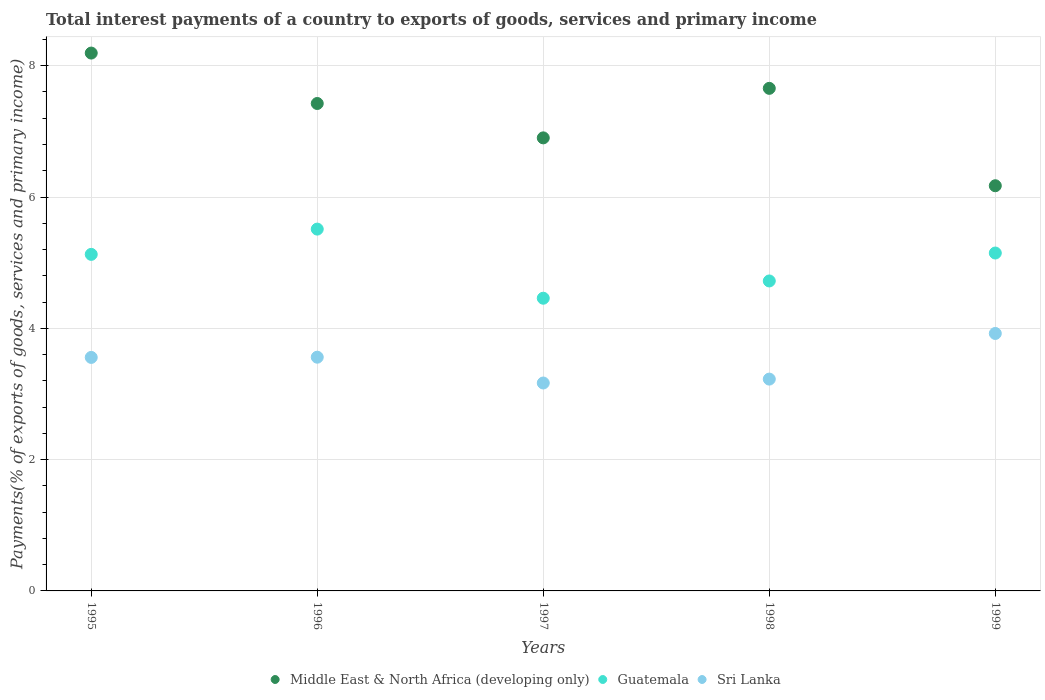Is the number of dotlines equal to the number of legend labels?
Keep it short and to the point. Yes. What is the total interest payments in Guatemala in 1997?
Offer a terse response. 4.46. Across all years, what is the maximum total interest payments in Sri Lanka?
Make the answer very short. 3.92. Across all years, what is the minimum total interest payments in Sri Lanka?
Your answer should be compact. 3.17. What is the total total interest payments in Guatemala in the graph?
Give a very brief answer. 24.96. What is the difference between the total interest payments in Guatemala in 1996 and that in 1998?
Offer a very short reply. 0.79. What is the difference between the total interest payments in Middle East & North Africa (developing only) in 1995 and the total interest payments in Sri Lanka in 1997?
Keep it short and to the point. 5.03. What is the average total interest payments in Guatemala per year?
Your answer should be very brief. 4.99. In the year 1998, what is the difference between the total interest payments in Guatemala and total interest payments in Middle East & North Africa (developing only)?
Provide a succinct answer. -2.93. In how many years, is the total interest payments in Sri Lanka greater than 1.2000000000000002 %?
Your response must be concise. 5. What is the ratio of the total interest payments in Middle East & North Africa (developing only) in 1995 to that in 1996?
Your response must be concise. 1.1. What is the difference between the highest and the second highest total interest payments in Guatemala?
Provide a succinct answer. 0.36. What is the difference between the highest and the lowest total interest payments in Sri Lanka?
Make the answer very short. 0.75. Is the sum of the total interest payments in Guatemala in 1996 and 1998 greater than the maximum total interest payments in Middle East & North Africa (developing only) across all years?
Keep it short and to the point. Yes. Is it the case that in every year, the sum of the total interest payments in Guatemala and total interest payments in Middle East & North Africa (developing only)  is greater than the total interest payments in Sri Lanka?
Give a very brief answer. Yes. Is the total interest payments in Guatemala strictly greater than the total interest payments in Sri Lanka over the years?
Keep it short and to the point. Yes. How many dotlines are there?
Offer a terse response. 3. What is the difference between two consecutive major ticks on the Y-axis?
Offer a very short reply. 2. Are the values on the major ticks of Y-axis written in scientific E-notation?
Keep it short and to the point. No. Does the graph contain grids?
Offer a very short reply. Yes. Where does the legend appear in the graph?
Make the answer very short. Bottom center. What is the title of the graph?
Keep it short and to the point. Total interest payments of a country to exports of goods, services and primary income. Does "St. Martin (French part)" appear as one of the legend labels in the graph?
Provide a short and direct response. No. What is the label or title of the X-axis?
Provide a short and direct response. Years. What is the label or title of the Y-axis?
Ensure brevity in your answer.  Payments(% of exports of goods, services and primary income). What is the Payments(% of exports of goods, services and primary income) of Middle East & North Africa (developing only) in 1995?
Offer a terse response. 8.19. What is the Payments(% of exports of goods, services and primary income) in Guatemala in 1995?
Your answer should be compact. 5.13. What is the Payments(% of exports of goods, services and primary income) of Sri Lanka in 1995?
Ensure brevity in your answer.  3.56. What is the Payments(% of exports of goods, services and primary income) in Middle East & North Africa (developing only) in 1996?
Offer a very short reply. 7.42. What is the Payments(% of exports of goods, services and primary income) in Guatemala in 1996?
Your answer should be very brief. 5.51. What is the Payments(% of exports of goods, services and primary income) of Sri Lanka in 1996?
Your answer should be compact. 3.56. What is the Payments(% of exports of goods, services and primary income) of Middle East & North Africa (developing only) in 1997?
Your answer should be very brief. 6.9. What is the Payments(% of exports of goods, services and primary income) in Guatemala in 1997?
Provide a succinct answer. 4.46. What is the Payments(% of exports of goods, services and primary income) of Sri Lanka in 1997?
Keep it short and to the point. 3.17. What is the Payments(% of exports of goods, services and primary income) in Middle East & North Africa (developing only) in 1998?
Your answer should be compact. 7.66. What is the Payments(% of exports of goods, services and primary income) of Guatemala in 1998?
Give a very brief answer. 4.72. What is the Payments(% of exports of goods, services and primary income) in Sri Lanka in 1998?
Offer a very short reply. 3.23. What is the Payments(% of exports of goods, services and primary income) of Middle East & North Africa (developing only) in 1999?
Provide a succinct answer. 6.17. What is the Payments(% of exports of goods, services and primary income) in Guatemala in 1999?
Your answer should be compact. 5.15. What is the Payments(% of exports of goods, services and primary income) of Sri Lanka in 1999?
Provide a succinct answer. 3.92. Across all years, what is the maximum Payments(% of exports of goods, services and primary income) in Middle East & North Africa (developing only)?
Offer a terse response. 8.19. Across all years, what is the maximum Payments(% of exports of goods, services and primary income) of Guatemala?
Your answer should be very brief. 5.51. Across all years, what is the maximum Payments(% of exports of goods, services and primary income) in Sri Lanka?
Your answer should be very brief. 3.92. Across all years, what is the minimum Payments(% of exports of goods, services and primary income) of Middle East & North Africa (developing only)?
Your answer should be compact. 6.17. Across all years, what is the minimum Payments(% of exports of goods, services and primary income) of Guatemala?
Offer a very short reply. 4.46. Across all years, what is the minimum Payments(% of exports of goods, services and primary income) in Sri Lanka?
Your answer should be compact. 3.17. What is the total Payments(% of exports of goods, services and primary income) of Middle East & North Africa (developing only) in the graph?
Your answer should be very brief. 36.34. What is the total Payments(% of exports of goods, services and primary income) in Guatemala in the graph?
Provide a succinct answer. 24.96. What is the total Payments(% of exports of goods, services and primary income) in Sri Lanka in the graph?
Offer a terse response. 17.43. What is the difference between the Payments(% of exports of goods, services and primary income) of Middle East & North Africa (developing only) in 1995 and that in 1996?
Your response must be concise. 0.77. What is the difference between the Payments(% of exports of goods, services and primary income) of Guatemala in 1995 and that in 1996?
Provide a succinct answer. -0.38. What is the difference between the Payments(% of exports of goods, services and primary income) of Sri Lanka in 1995 and that in 1996?
Make the answer very short. -0. What is the difference between the Payments(% of exports of goods, services and primary income) in Middle East & North Africa (developing only) in 1995 and that in 1997?
Provide a short and direct response. 1.29. What is the difference between the Payments(% of exports of goods, services and primary income) of Guatemala in 1995 and that in 1997?
Ensure brevity in your answer.  0.67. What is the difference between the Payments(% of exports of goods, services and primary income) in Sri Lanka in 1995 and that in 1997?
Ensure brevity in your answer.  0.39. What is the difference between the Payments(% of exports of goods, services and primary income) of Middle East & North Africa (developing only) in 1995 and that in 1998?
Your answer should be very brief. 0.54. What is the difference between the Payments(% of exports of goods, services and primary income) of Guatemala in 1995 and that in 1998?
Give a very brief answer. 0.41. What is the difference between the Payments(% of exports of goods, services and primary income) of Sri Lanka in 1995 and that in 1998?
Make the answer very short. 0.33. What is the difference between the Payments(% of exports of goods, services and primary income) in Middle East & North Africa (developing only) in 1995 and that in 1999?
Provide a succinct answer. 2.02. What is the difference between the Payments(% of exports of goods, services and primary income) in Guatemala in 1995 and that in 1999?
Offer a very short reply. -0.02. What is the difference between the Payments(% of exports of goods, services and primary income) in Sri Lanka in 1995 and that in 1999?
Keep it short and to the point. -0.36. What is the difference between the Payments(% of exports of goods, services and primary income) of Middle East & North Africa (developing only) in 1996 and that in 1997?
Ensure brevity in your answer.  0.52. What is the difference between the Payments(% of exports of goods, services and primary income) of Guatemala in 1996 and that in 1997?
Your response must be concise. 1.05. What is the difference between the Payments(% of exports of goods, services and primary income) of Sri Lanka in 1996 and that in 1997?
Offer a very short reply. 0.39. What is the difference between the Payments(% of exports of goods, services and primary income) in Middle East & North Africa (developing only) in 1996 and that in 1998?
Your answer should be very brief. -0.23. What is the difference between the Payments(% of exports of goods, services and primary income) in Guatemala in 1996 and that in 1998?
Give a very brief answer. 0.79. What is the difference between the Payments(% of exports of goods, services and primary income) of Sri Lanka in 1996 and that in 1998?
Offer a terse response. 0.33. What is the difference between the Payments(% of exports of goods, services and primary income) of Middle East & North Africa (developing only) in 1996 and that in 1999?
Make the answer very short. 1.25. What is the difference between the Payments(% of exports of goods, services and primary income) of Guatemala in 1996 and that in 1999?
Your answer should be very brief. 0.36. What is the difference between the Payments(% of exports of goods, services and primary income) of Sri Lanka in 1996 and that in 1999?
Provide a short and direct response. -0.36. What is the difference between the Payments(% of exports of goods, services and primary income) in Middle East & North Africa (developing only) in 1997 and that in 1998?
Provide a succinct answer. -0.75. What is the difference between the Payments(% of exports of goods, services and primary income) in Guatemala in 1997 and that in 1998?
Offer a terse response. -0.26. What is the difference between the Payments(% of exports of goods, services and primary income) of Sri Lanka in 1997 and that in 1998?
Provide a short and direct response. -0.06. What is the difference between the Payments(% of exports of goods, services and primary income) of Middle East & North Africa (developing only) in 1997 and that in 1999?
Provide a succinct answer. 0.73. What is the difference between the Payments(% of exports of goods, services and primary income) of Guatemala in 1997 and that in 1999?
Make the answer very short. -0.69. What is the difference between the Payments(% of exports of goods, services and primary income) in Sri Lanka in 1997 and that in 1999?
Provide a succinct answer. -0.75. What is the difference between the Payments(% of exports of goods, services and primary income) of Middle East & North Africa (developing only) in 1998 and that in 1999?
Give a very brief answer. 1.48. What is the difference between the Payments(% of exports of goods, services and primary income) of Guatemala in 1998 and that in 1999?
Provide a short and direct response. -0.43. What is the difference between the Payments(% of exports of goods, services and primary income) of Sri Lanka in 1998 and that in 1999?
Offer a very short reply. -0.69. What is the difference between the Payments(% of exports of goods, services and primary income) in Middle East & North Africa (developing only) in 1995 and the Payments(% of exports of goods, services and primary income) in Guatemala in 1996?
Provide a short and direct response. 2.68. What is the difference between the Payments(% of exports of goods, services and primary income) of Middle East & North Africa (developing only) in 1995 and the Payments(% of exports of goods, services and primary income) of Sri Lanka in 1996?
Offer a terse response. 4.63. What is the difference between the Payments(% of exports of goods, services and primary income) in Guatemala in 1995 and the Payments(% of exports of goods, services and primary income) in Sri Lanka in 1996?
Offer a terse response. 1.57. What is the difference between the Payments(% of exports of goods, services and primary income) of Middle East & North Africa (developing only) in 1995 and the Payments(% of exports of goods, services and primary income) of Guatemala in 1997?
Offer a terse response. 3.73. What is the difference between the Payments(% of exports of goods, services and primary income) of Middle East & North Africa (developing only) in 1995 and the Payments(% of exports of goods, services and primary income) of Sri Lanka in 1997?
Your answer should be compact. 5.03. What is the difference between the Payments(% of exports of goods, services and primary income) in Guatemala in 1995 and the Payments(% of exports of goods, services and primary income) in Sri Lanka in 1997?
Provide a succinct answer. 1.96. What is the difference between the Payments(% of exports of goods, services and primary income) of Middle East & North Africa (developing only) in 1995 and the Payments(% of exports of goods, services and primary income) of Guatemala in 1998?
Make the answer very short. 3.47. What is the difference between the Payments(% of exports of goods, services and primary income) in Middle East & North Africa (developing only) in 1995 and the Payments(% of exports of goods, services and primary income) in Sri Lanka in 1998?
Ensure brevity in your answer.  4.97. What is the difference between the Payments(% of exports of goods, services and primary income) of Guatemala in 1995 and the Payments(% of exports of goods, services and primary income) of Sri Lanka in 1998?
Provide a short and direct response. 1.9. What is the difference between the Payments(% of exports of goods, services and primary income) in Middle East & North Africa (developing only) in 1995 and the Payments(% of exports of goods, services and primary income) in Guatemala in 1999?
Keep it short and to the point. 3.05. What is the difference between the Payments(% of exports of goods, services and primary income) of Middle East & North Africa (developing only) in 1995 and the Payments(% of exports of goods, services and primary income) of Sri Lanka in 1999?
Offer a very short reply. 4.27. What is the difference between the Payments(% of exports of goods, services and primary income) in Guatemala in 1995 and the Payments(% of exports of goods, services and primary income) in Sri Lanka in 1999?
Offer a terse response. 1.2. What is the difference between the Payments(% of exports of goods, services and primary income) of Middle East & North Africa (developing only) in 1996 and the Payments(% of exports of goods, services and primary income) of Guatemala in 1997?
Your answer should be compact. 2.97. What is the difference between the Payments(% of exports of goods, services and primary income) of Middle East & North Africa (developing only) in 1996 and the Payments(% of exports of goods, services and primary income) of Sri Lanka in 1997?
Your answer should be very brief. 4.26. What is the difference between the Payments(% of exports of goods, services and primary income) in Guatemala in 1996 and the Payments(% of exports of goods, services and primary income) in Sri Lanka in 1997?
Provide a short and direct response. 2.34. What is the difference between the Payments(% of exports of goods, services and primary income) of Middle East & North Africa (developing only) in 1996 and the Payments(% of exports of goods, services and primary income) of Guatemala in 1998?
Your response must be concise. 2.7. What is the difference between the Payments(% of exports of goods, services and primary income) in Middle East & North Africa (developing only) in 1996 and the Payments(% of exports of goods, services and primary income) in Sri Lanka in 1998?
Give a very brief answer. 4.2. What is the difference between the Payments(% of exports of goods, services and primary income) in Guatemala in 1996 and the Payments(% of exports of goods, services and primary income) in Sri Lanka in 1998?
Provide a short and direct response. 2.28. What is the difference between the Payments(% of exports of goods, services and primary income) in Middle East & North Africa (developing only) in 1996 and the Payments(% of exports of goods, services and primary income) in Guatemala in 1999?
Your answer should be compact. 2.28. What is the difference between the Payments(% of exports of goods, services and primary income) in Middle East & North Africa (developing only) in 1996 and the Payments(% of exports of goods, services and primary income) in Sri Lanka in 1999?
Offer a very short reply. 3.5. What is the difference between the Payments(% of exports of goods, services and primary income) in Guatemala in 1996 and the Payments(% of exports of goods, services and primary income) in Sri Lanka in 1999?
Offer a very short reply. 1.59. What is the difference between the Payments(% of exports of goods, services and primary income) of Middle East & North Africa (developing only) in 1997 and the Payments(% of exports of goods, services and primary income) of Guatemala in 1998?
Your response must be concise. 2.18. What is the difference between the Payments(% of exports of goods, services and primary income) in Middle East & North Africa (developing only) in 1997 and the Payments(% of exports of goods, services and primary income) in Sri Lanka in 1998?
Your response must be concise. 3.67. What is the difference between the Payments(% of exports of goods, services and primary income) of Guatemala in 1997 and the Payments(% of exports of goods, services and primary income) of Sri Lanka in 1998?
Keep it short and to the point. 1.23. What is the difference between the Payments(% of exports of goods, services and primary income) in Middle East & North Africa (developing only) in 1997 and the Payments(% of exports of goods, services and primary income) in Guatemala in 1999?
Ensure brevity in your answer.  1.75. What is the difference between the Payments(% of exports of goods, services and primary income) of Middle East & North Africa (developing only) in 1997 and the Payments(% of exports of goods, services and primary income) of Sri Lanka in 1999?
Ensure brevity in your answer.  2.98. What is the difference between the Payments(% of exports of goods, services and primary income) of Guatemala in 1997 and the Payments(% of exports of goods, services and primary income) of Sri Lanka in 1999?
Provide a succinct answer. 0.54. What is the difference between the Payments(% of exports of goods, services and primary income) of Middle East & North Africa (developing only) in 1998 and the Payments(% of exports of goods, services and primary income) of Guatemala in 1999?
Give a very brief answer. 2.51. What is the difference between the Payments(% of exports of goods, services and primary income) in Middle East & North Africa (developing only) in 1998 and the Payments(% of exports of goods, services and primary income) in Sri Lanka in 1999?
Offer a terse response. 3.73. What is the difference between the Payments(% of exports of goods, services and primary income) of Guatemala in 1998 and the Payments(% of exports of goods, services and primary income) of Sri Lanka in 1999?
Offer a very short reply. 0.8. What is the average Payments(% of exports of goods, services and primary income) in Middle East & North Africa (developing only) per year?
Offer a very short reply. 7.27. What is the average Payments(% of exports of goods, services and primary income) of Guatemala per year?
Offer a terse response. 4.99. What is the average Payments(% of exports of goods, services and primary income) of Sri Lanka per year?
Offer a terse response. 3.49. In the year 1995, what is the difference between the Payments(% of exports of goods, services and primary income) in Middle East & North Africa (developing only) and Payments(% of exports of goods, services and primary income) in Guatemala?
Give a very brief answer. 3.07. In the year 1995, what is the difference between the Payments(% of exports of goods, services and primary income) in Middle East & North Africa (developing only) and Payments(% of exports of goods, services and primary income) in Sri Lanka?
Your answer should be compact. 4.64. In the year 1995, what is the difference between the Payments(% of exports of goods, services and primary income) of Guatemala and Payments(% of exports of goods, services and primary income) of Sri Lanka?
Make the answer very short. 1.57. In the year 1996, what is the difference between the Payments(% of exports of goods, services and primary income) of Middle East & North Africa (developing only) and Payments(% of exports of goods, services and primary income) of Guatemala?
Your answer should be very brief. 1.91. In the year 1996, what is the difference between the Payments(% of exports of goods, services and primary income) of Middle East & North Africa (developing only) and Payments(% of exports of goods, services and primary income) of Sri Lanka?
Make the answer very short. 3.86. In the year 1996, what is the difference between the Payments(% of exports of goods, services and primary income) of Guatemala and Payments(% of exports of goods, services and primary income) of Sri Lanka?
Give a very brief answer. 1.95. In the year 1997, what is the difference between the Payments(% of exports of goods, services and primary income) in Middle East & North Africa (developing only) and Payments(% of exports of goods, services and primary income) in Guatemala?
Your response must be concise. 2.44. In the year 1997, what is the difference between the Payments(% of exports of goods, services and primary income) of Middle East & North Africa (developing only) and Payments(% of exports of goods, services and primary income) of Sri Lanka?
Offer a very short reply. 3.73. In the year 1997, what is the difference between the Payments(% of exports of goods, services and primary income) in Guatemala and Payments(% of exports of goods, services and primary income) in Sri Lanka?
Your answer should be very brief. 1.29. In the year 1998, what is the difference between the Payments(% of exports of goods, services and primary income) in Middle East & North Africa (developing only) and Payments(% of exports of goods, services and primary income) in Guatemala?
Offer a terse response. 2.93. In the year 1998, what is the difference between the Payments(% of exports of goods, services and primary income) of Middle East & North Africa (developing only) and Payments(% of exports of goods, services and primary income) of Sri Lanka?
Provide a succinct answer. 4.43. In the year 1998, what is the difference between the Payments(% of exports of goods, services and primary income) in Guatemala and Payments(% of exports of goods, services and primary income) in Sri Lanka?
Provide a succinct answer. 1.49. In the year 1999, what is the difference between the Payments(% of exports of goods, services and primary income) in Middle East & North Africa (developing only) and Payments(% of exports of goods, services and primary income) in Guatemala?
Offer a terse response. 1.02. In the year 1999, what is the difference between the Payments(% of exports of goods, services and primary income) in Middle East & North Africa (developing only) and Payments(% of exports of goods, services and primary income) in Sri Lanka?
Your answer should be very brief. 2.25. In the year 1999, what is the difference between the Payments(% of exports of goods, services and primary income) of Guatemala and Payments(% of exports of goods, services and primary income) of Sri Lanka?
Keep it short and to the point. 1.23. What is the ratio of the Payments(% of exports of goods, services and primary income) in Middle East & North Africa (developing only) in 1995 to that in 1996?
Your response must be concise. 1.1. What is the ratio of the Payments(% of exports of goods, services and primary income) of Guatemala in 1995 to that in 1996?
Provide a succinct answer. 0.93. What is the ratio of the Payments(% of exports of goods, services and primary income) of Sri Lanka in 1995 to that in 1996?
Give a very brief answer. 1. What is the ratio of the Payments(% of exports of goods, services and primary income) of Middle East & North Africa (developing only) in 1995 to that in 1997?
Your answer should be very brief. 1.19. What is the ratio of the Payments(% of exports of goods, services and primary income) in Guatemala in 1995 to that in 1997?
Provide a short and direct response. 1.15. What is the ratio of the Payments(% of exports of goods, services and primary income) of Sri Lanka in 1995 to that in 1997?
Provide a succinct answer. 1.12. What is the ratio of the Payments(% of exports of goods, services and primary income) of Middle East & North Africa (developing only) in 1995 to that in 1998?
Offer a very short reply. 1.07. What is the ratio of the Payments(% of exports of goods, services and primary income) of Guatemala in 1995 to that in 1998?
Your answer should be compact. 1.09. What is the ratio of the Payments(% of exports of goods, services and primary income) in Sri Lanka in 1995 to that in 1998?
Offer a very short reply. 1.1. What is the ratio of the Payments(% of exports of goods, services and primary income) of Middle East & North Africa (developing only) in 1995 to that in 1999?
Give a very brief answer. 1.33. What is the ratio of the Payments(% of exports of goods, services and primary income) in Guatemala in 1995 to that in 1999?
Your response must be concise. 1. What is the ratio of the Payments(% of exports of goods, services and primary income) of Sri Lanka in 1995 to that in 1999?
Your answer should be compact. 0.91. What is the ratio of the Payments(% of exports of goods, services and primary income) in Middle East & North Africa (developing only) in 1996 to that in 1997?
Ensure brevity in your answer.  1.08. What is the ratio of the Payments(% of exports of goods, services and primary income) of Guatemala in 1996 to that in 1997?
Provide a succinct answer. 1.24. What is the ratio of the Payments(% of exports of goods, services and primary income) in Sri Lanka in 1996 to that in 1997?
Your response must be concise. 1.12. What is the ratio of the Payments(% of exports of goods, services and primary income) of Middle East & North Africa (developing only) in 1996 to that in 1998?
Offer a terse response. 0.97. What is the ratio of the Payments(% of exports of goods, services and primary income) in Guatemala in 1996 to that in 1998?
Your answer should be very brief. 1.17. What is the ratio of the Payments(% of exports of goods, services and primary income) of Sri Lanka in 1996 to that in 1998?
Offer a very short reply. 1.1. What is the ratio of the Payments(% of exports of goods, services and primary income) of Middle East & North Africa (developing only) in 1996 to that in 1999?
Provide a succinct answer. 1.2. What is the ratio of the Payments(% of exports of goods, services and primary income) in Guatemala in 1996 to that in 1999?
Make the answer very short. 1.07. What is the ratio of the Payments(% of exports of goods, services and primary income) in Sri Lanka in 1996 to that in 1999?
Your answer should be very brief. 0.91. What is the ratio of the Payments(% of exports of goods, services and primary income) in Middle East & North Africa (developing only) in 1997 to that in 1998?
Your answer should be very brief. 0.9. What is the ratio of the Payments(% of exports of goods, services and primary income) of Guatemala in 1997 to that in 1998?
Keep it short and to the point. 0.94. What is the ratio of the Payments(% of exports of goods, services and primary income) of Sri Lanka in 1997 to that in 1998?
Keep it short and to the point. 0.98. What is the ratio of the Payments(% of exports of goods, services and primary income) in Middle East & North Africa (developing only) in 1997 to that in 1999?
Provide a short and direct response. 1.12. What is the ratio of the Payments(% of exports of goods, services and primary income) of Guatemala in 1997 to that in 1999?
Offer a terse response. 0.87. What is the ratio of the Payments(% of exports of goods, services and primary income) in Sri Lanka in 1997 to that in 1999?
Provide a short and direct response. 0.81. What is the ratio of the Payments(% of exports of goods, services and primary income) of Middle East & North Africa (developing only) in 1998 to that in 1999?
Keep it short and to the point. 1.24. What is the ratio of the Payments(% of exports of goods, services and primary income) in Guatemala in 1998 to that in 1999?
Your answer should be compact. 0.92. What is the ratio of the Payments(% of exports of goods, services and primary income) in Sri Lanka in 1998 to that in 1999?
Provide a succinct answer. 0.82. What is the difference between the highest and the second highest Payments(% of exports of goods, services and primary income) in Middle East & North Africa (developing only)?
Provide a succinct answer. 0.54. What is the difference between the highest and the second highest Payments(% of exports of goods, services and primary income) of Guatemala?
Give a very brief answer. 0.36. What is the difference between the highest and the second highest Payments(% of exports of goods, services and primary income) of Sri Lanka?
Your answer should be compact. 0.36. What is the difference between the highest and the lowest Payments(% of exports of goods, services and primary income) in Middle East & North Africa (developing only)?
Offer a terse response. 2.02. What is the difference between the highest and the lowest Payments(% of exports of goods, services and primary income) of Guatemala?
Offer a terse response. 1.05. What is the difference between the highest and the lowest Payments(% of exports of goods, services and primary income) of Sri Lanka?
Make the answer very short. 0.75. 